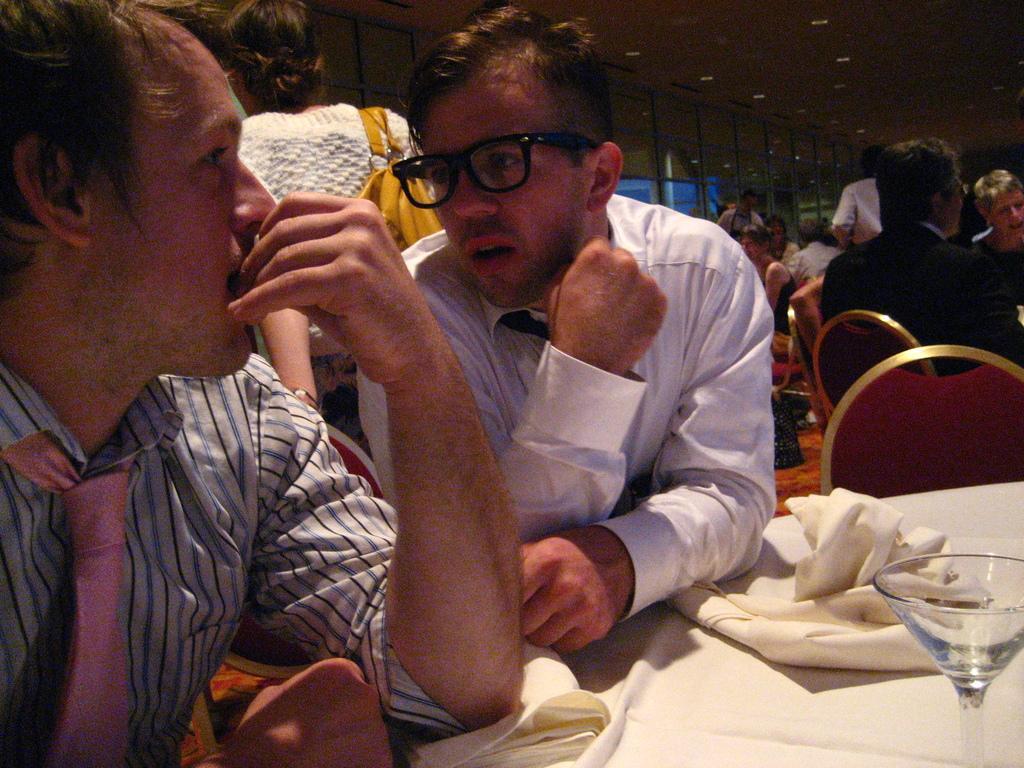Could you give a brief overview of what you see in this image? In this picture we can see a group of people, some people are sitting on chairs, some people are standing, here we can see clothes, glass and some objects and in the background we can see a roof, lights. 